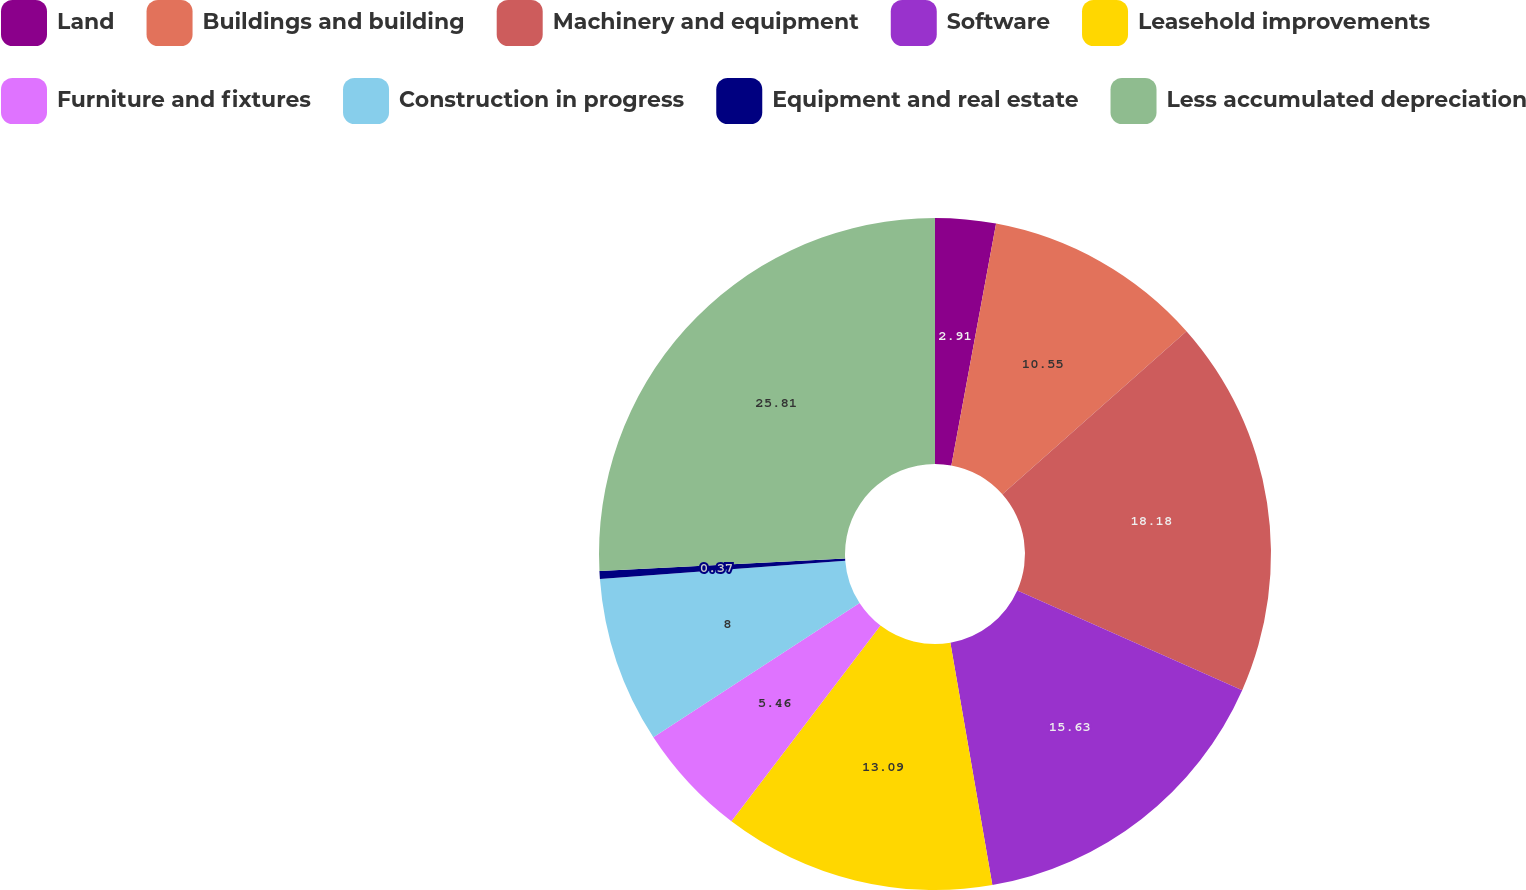Convert chart. <chart><loc_0><loc_0><loc_500><loc_500><pie_chart><fcel>Land<fcel>Buildings and building<fcel>Machinery and equipment<fcel>Software<fcel>Leasehold improvements<fcel>Furniture and fixtures<fcel>Construction in progress<fcel>Equipment and real estate<fcel>Less accumulated depreciation<nl><fcel>2.91%<fcel>10.55%<fcel>18.18%<fcel>15.63%<fcel>13.09%<fcel>5.46%<fcel>8.0%<fcel>0.37%<fcel>25.81%<nl></chart> 